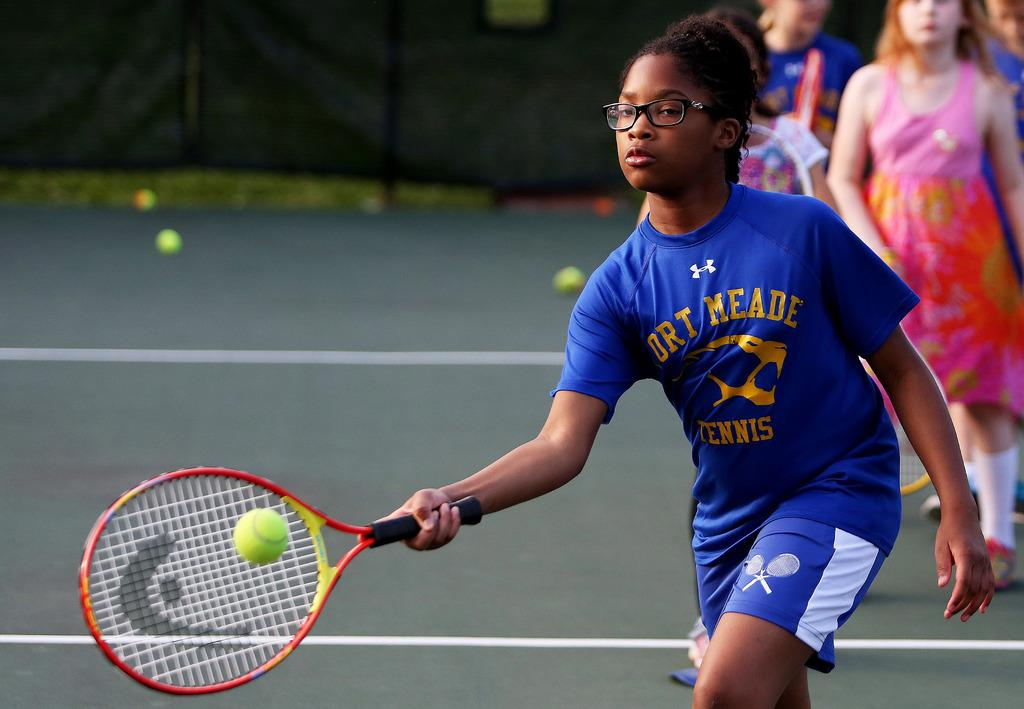How many people are present in the image? There are four people in the image. Can you describe the clothing of one of the women? One of the women is wearing a blue color shirt. What activity are the people engaged in? The woman is playing a tennis game. What type of drug can be seen in the image? There is no drug present in the image. How many toes are visible on the woman's feet in the image? The image does not show the woman's feet, so it is not possible to determine the number of toes visible. 